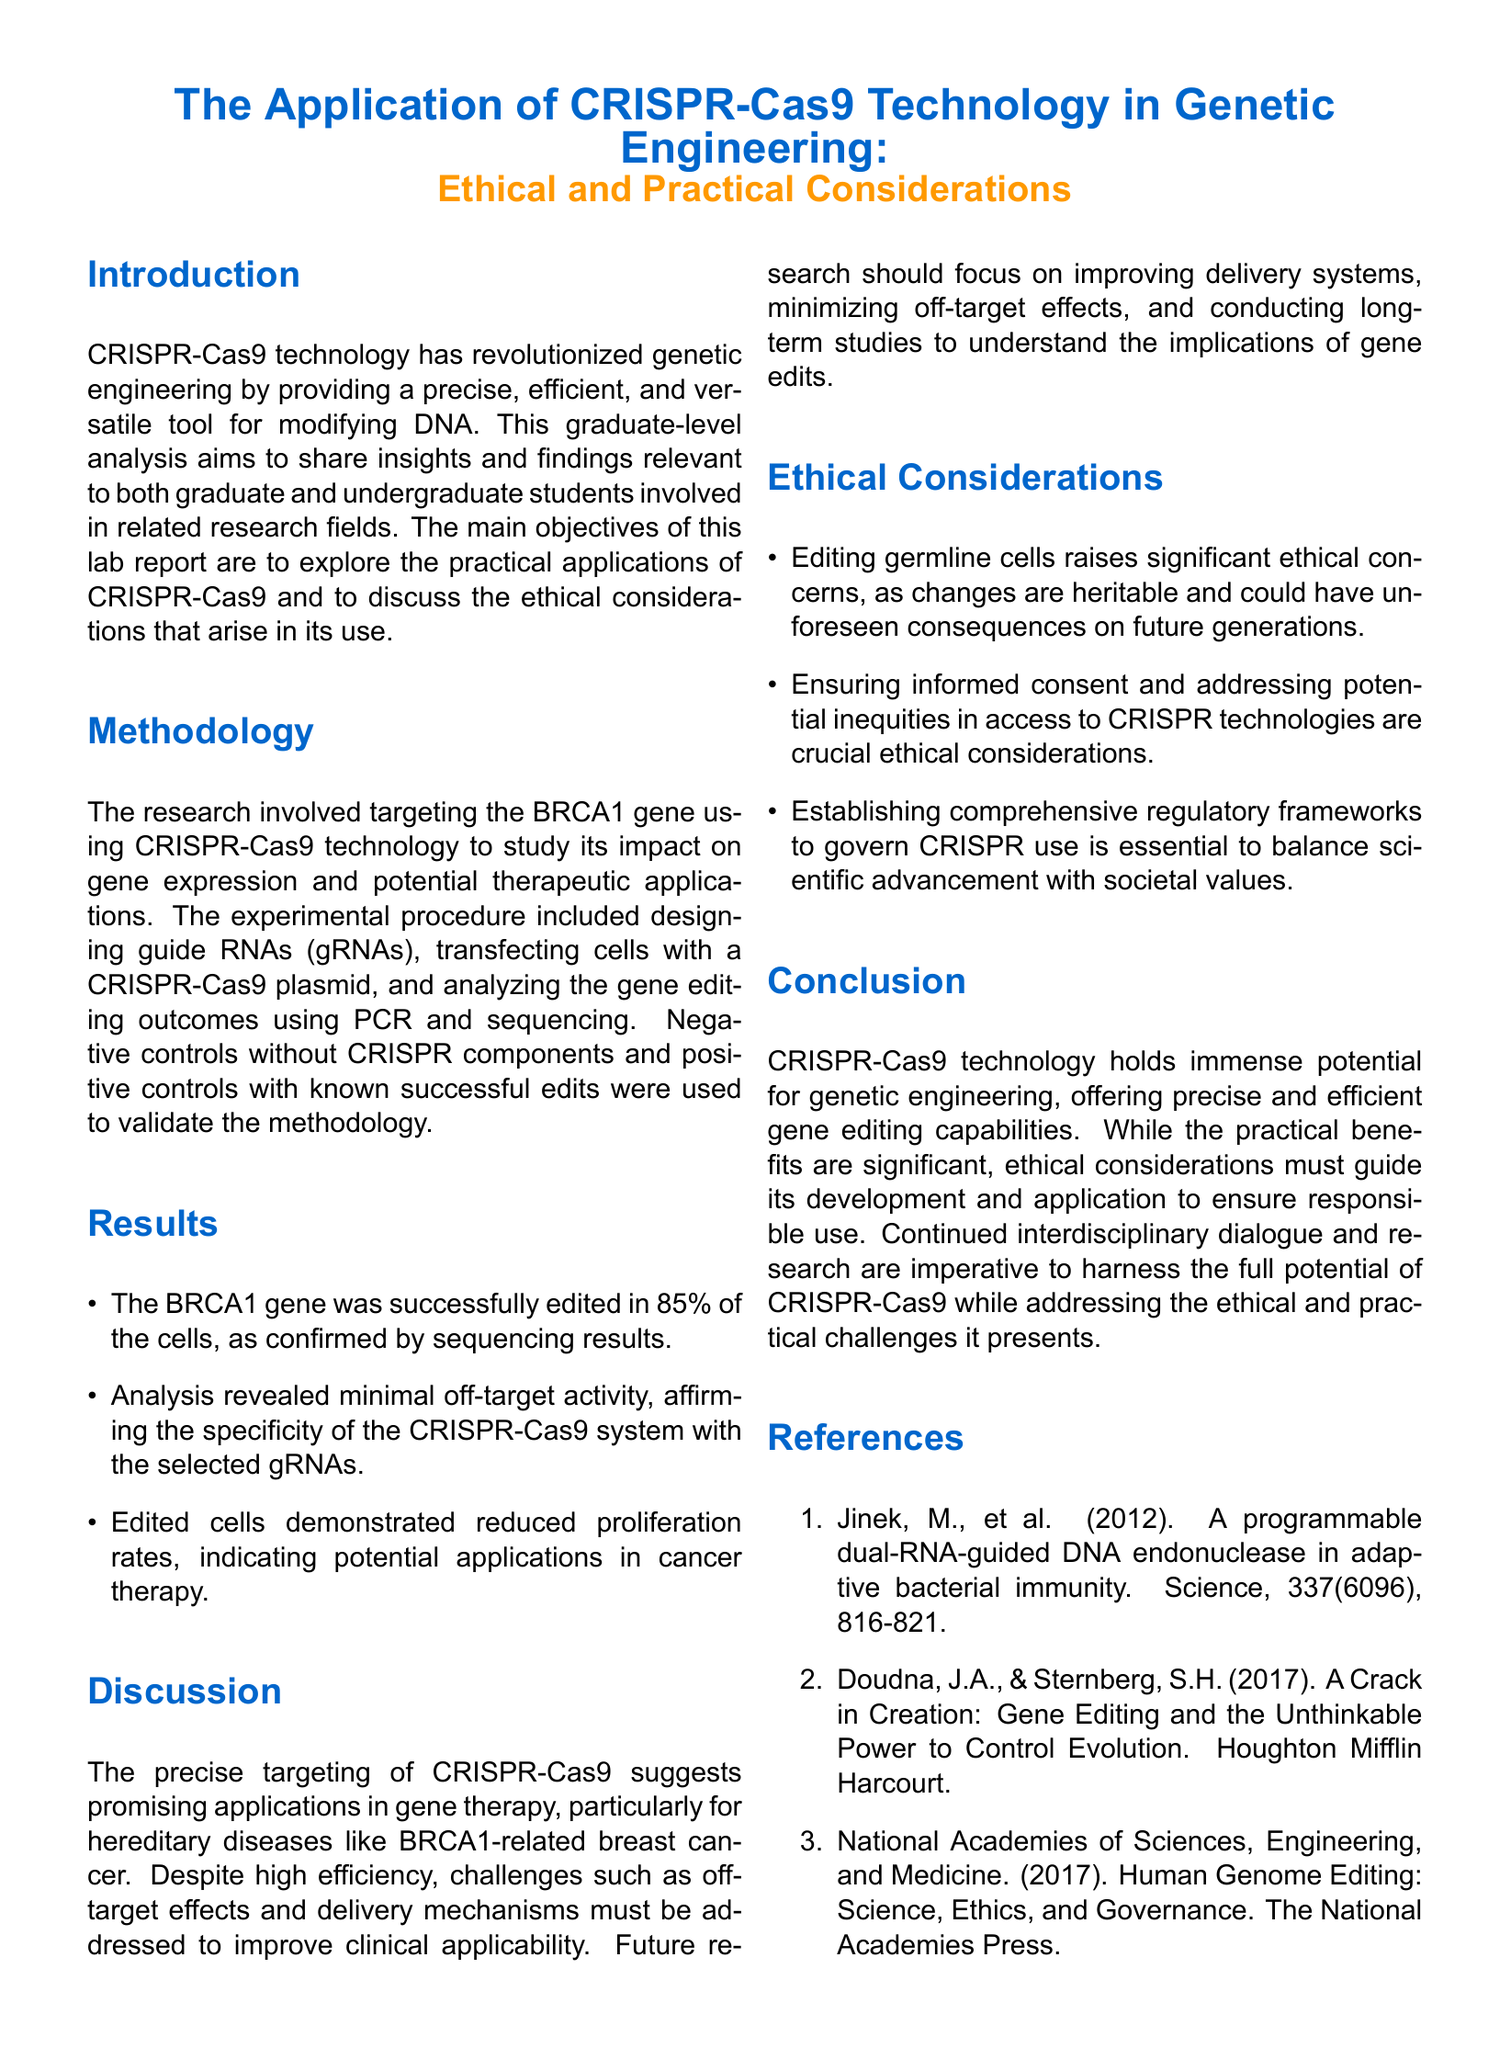What is the focus gene in the study? The report focuses on the BRCA1 gene, which is targeted for editing using CRISPR-Cas9 technology.
Answer: BRCA1 What percentage of cells were successfully edited? The results state that 85% of the cells were successfully edited, as confirmed by the sequencing results.
Answer: 85% What are the two main sections outlined in the discussion? The discussion covers practical applications and challenges of CRISPR-Cas9, along with suggestions for future research.
Answer: Practical applications and challenges Which type of cells raise ethical concerns when edited? The report highlights germline cells, as changes in these cells can be heritable and affect future generations.
Answer: Germline cells What technology is assessed in this lab report? The report evaluates CRISPR-Cas9 technology, explaining its precision and efficiency in genetic engineering.
Answer: CRISPR-Cas9 technology What is one ethical consideration mentioned regarding technology access? The report emphasizes the importance of addressing potential inequities in access to CRISPR technologies as a crucial ethical factor.
Answer: Inequities in access Which method was used for analyzing gene editing outcomes? The methodology describes the use of PCR and sequencing to analyze the outcomes of gene editing.
Answer: PCR and sequencing What is the primary objective of this lab report? The main objective is to explore the practical applications of CRISPR-Cas9 and to discuss the ethical considerations arising from its use.
Answer: Explore practical applications and discuss ethical considerations 